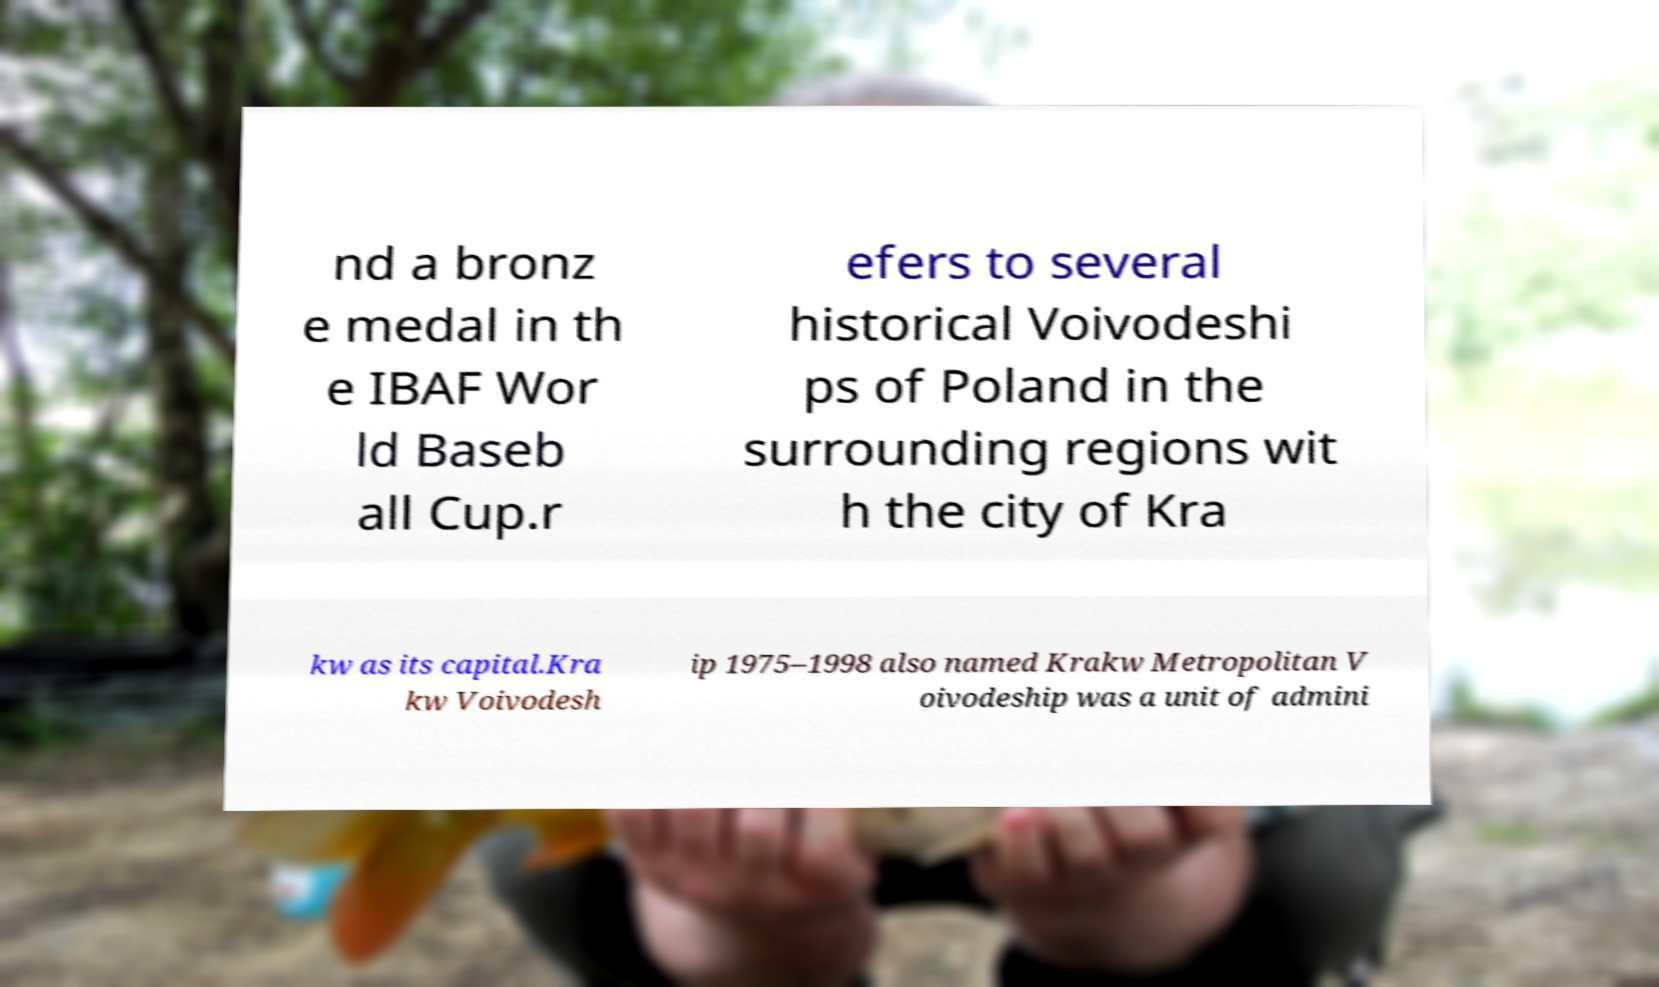Please read and relay the text visible in this image. What does it say? nd a bronz e medal in th e IBAF Wor ld Baseb all Cup.r efers to several historical Voivodeshi ps of Poland in the surrounding regions wit h the city of Kra kw as its capital.Kra kw Voivodesh ip 1975–1998 also named Krakw Metropolitan V oivodeship was a unit of admini 